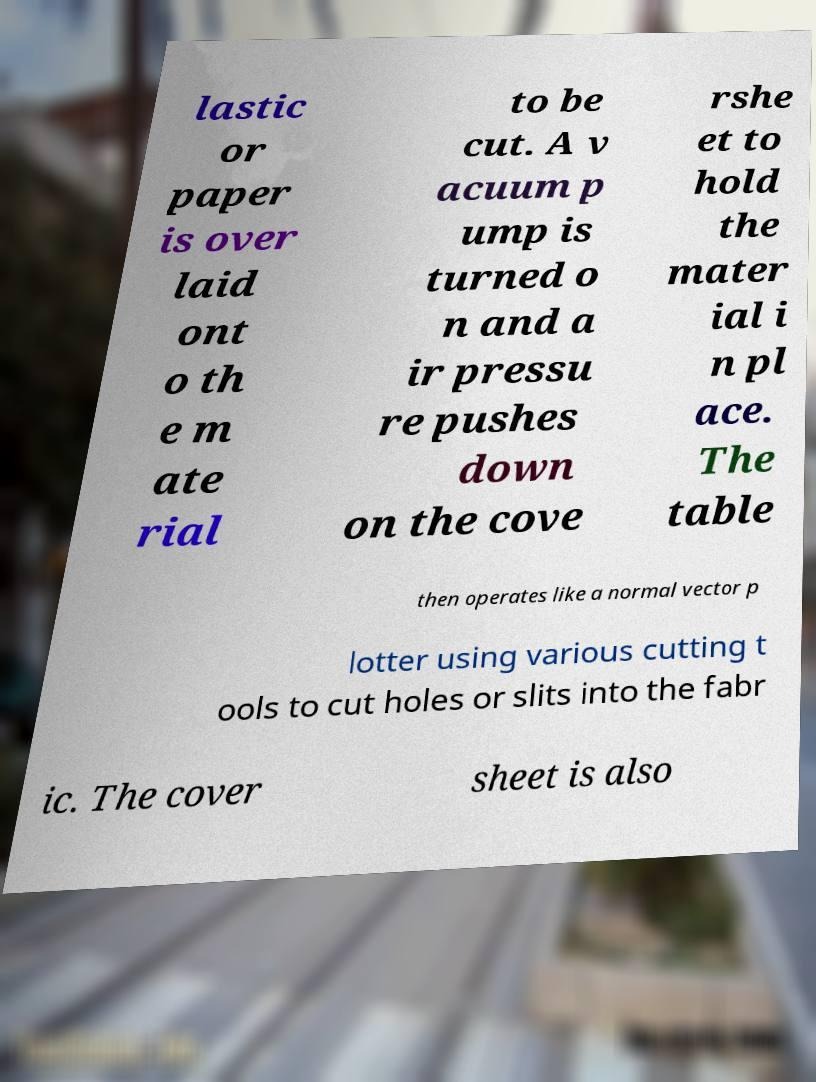Could you assist in decoding the text presented in this image and type it out clearly? lastic or paper is over laid ont o th e m ate rial to be cut. A v acuum p ump is turned o n and a ir pressu re pushes down on the cove rshe et to hold the mater ial i n pl ace. The table then operates like a normal vector p lotter using various cutting t ools to cut holes or slits into the fabr ic. The cover sheet is also 